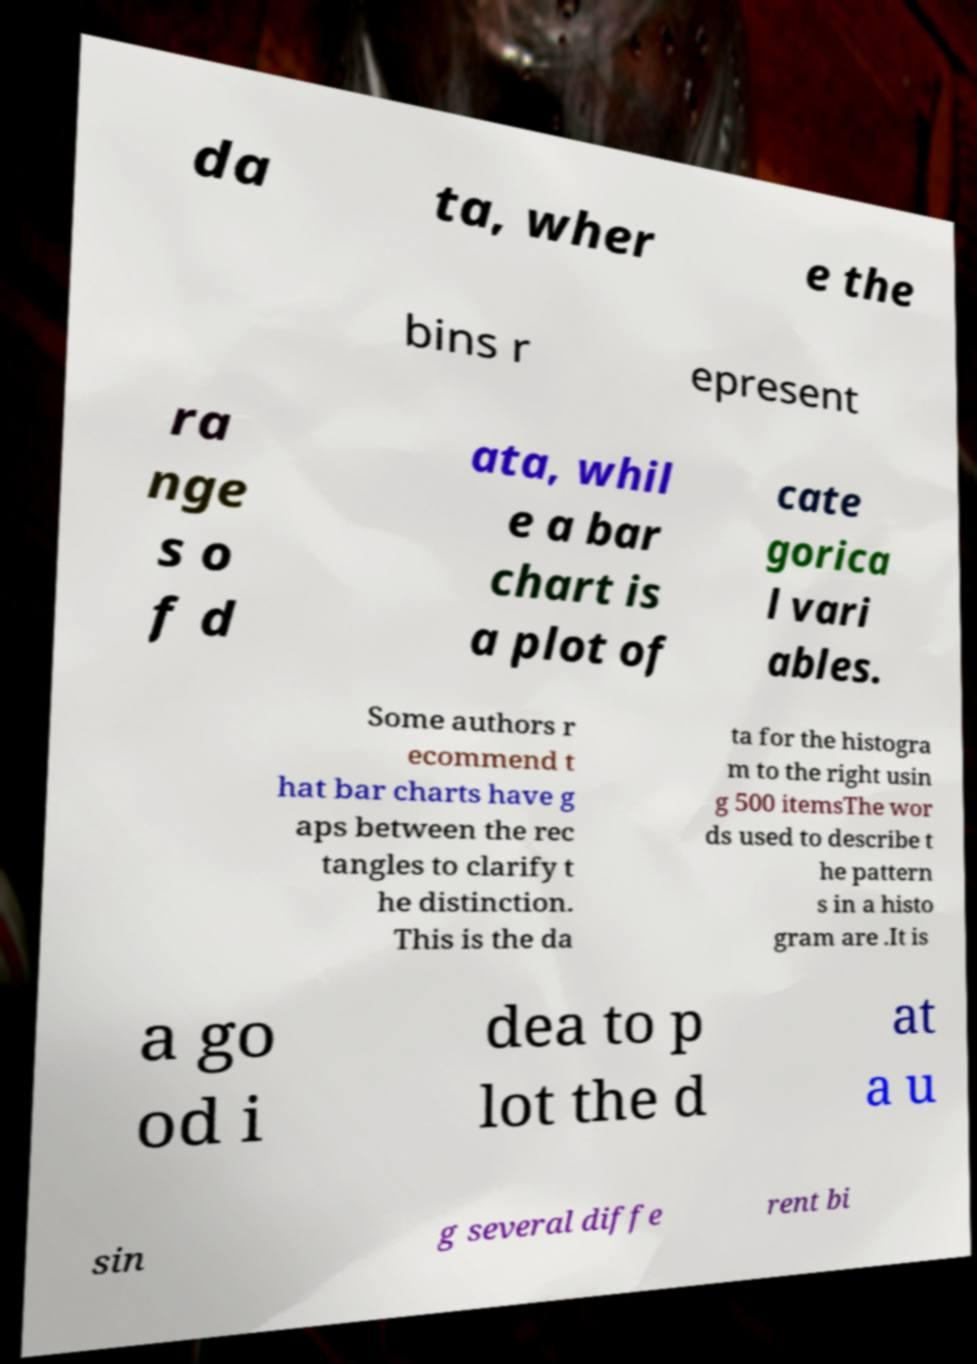Could you assist in decoding the text presented in this image and type it out clearly? da ta, wher e the bins r epresent ra nge s o f d ata, whil e a bar chart is a plot of cate gorica l vari ables. Some authors r ecommend t hat bar charts have g aps between the rec tangles to clarify t he distinction. This is the da ta for the histogra m to the right usin g 500 itemsThe wor ds used to describe t he pattern s in a histo gram are .It is a go od i dea to p lot the d at a u sin g several diffe rent bi 